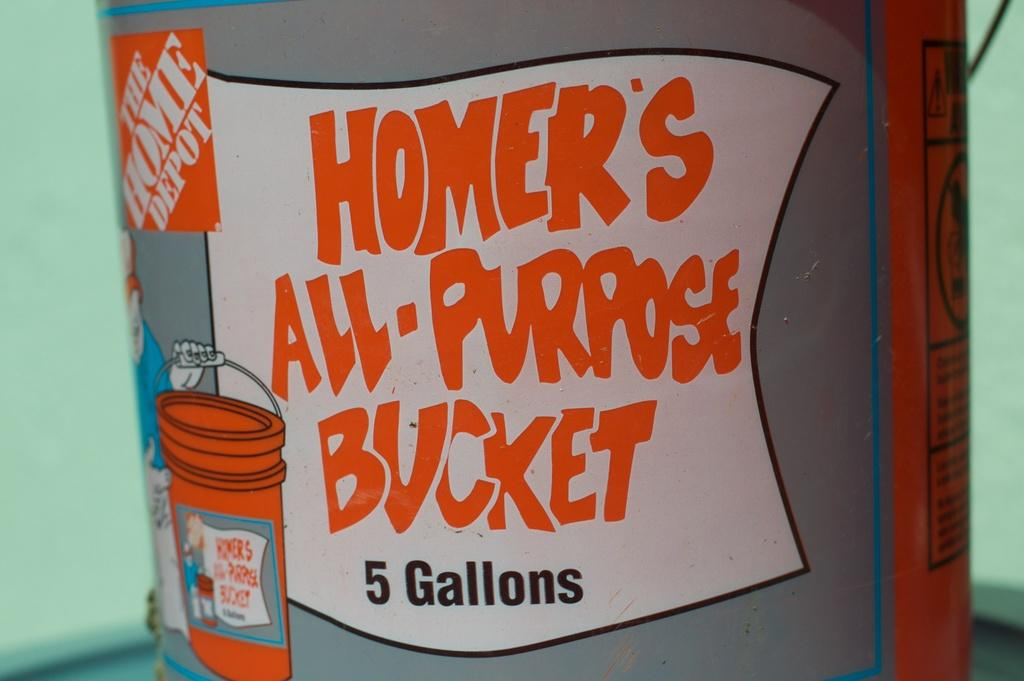<image>
Relay a brief, clear account of the picture shown. The logo of Homer's All purpose five gallon bucket written in orange. 